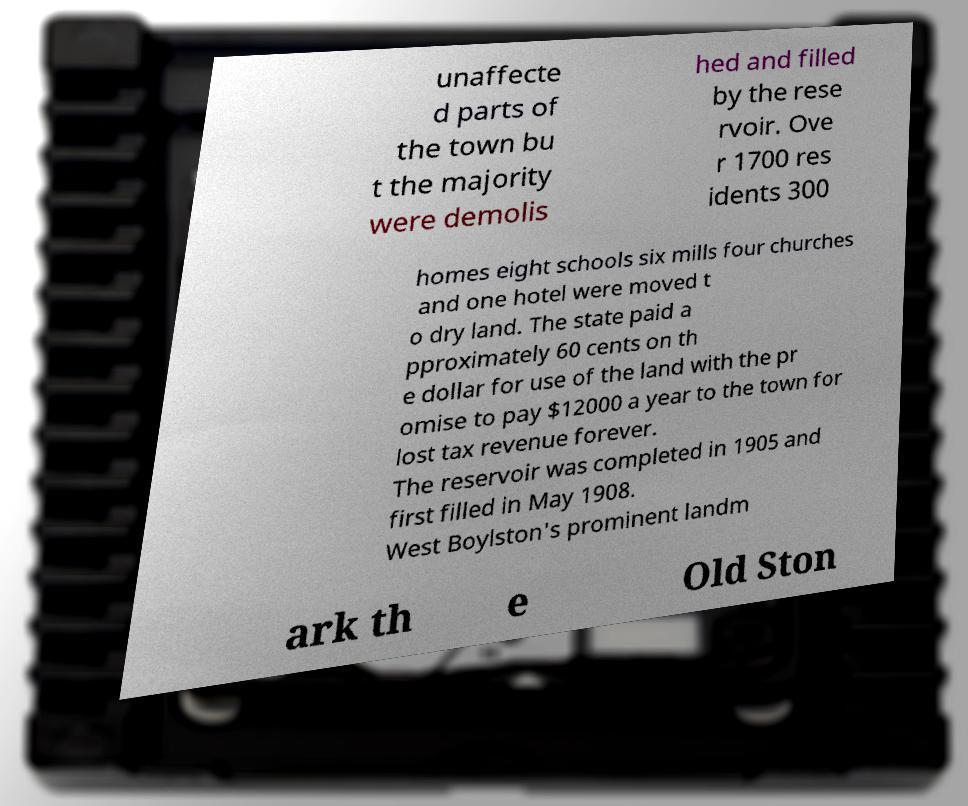Please identify and transcribe the text found in this image. unaffecte d parts of the town bu t the majority were demolis hed and filled by the rese rvoir. Ove r 1700 res idents 300 homes eight schools six mills four churches and one hotel were moved t o dry land. The state paid a pproximately 60 cents on th e dollar for use of the land with the pr omise to pay $12000 a year to the town for lost tax revenue forever. The reservoir was completed in 1905 and first filled in May 1908. West Boylston's prominent landm ark th e Old Ston 